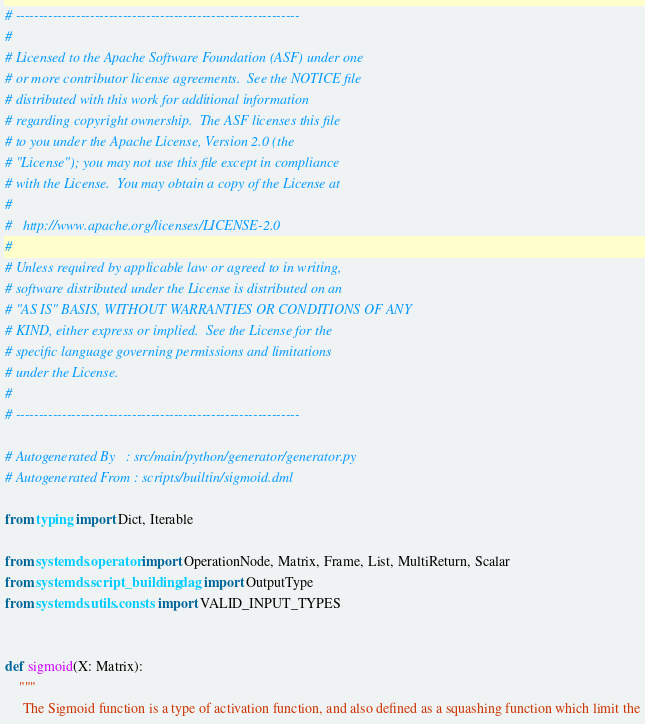<code> <loc_0><loc_0><loc_500><loc_500><_Python_># -------------------------------------------------------------
#
# Licensed to the Apache Software Foundation (ASF) under one
# or more contributor license agreements.  See the NOTICE file
# distributed with this work for additional information
# regarding copyright ownership.  The ASF licenses this file
# to you under the Apache License, Version 2.0 (the
# "License"); you may not use this file except in compliance
# with the License.  You may obtain a copy of the License at
#
#   http://www.apache.org/licenses/LICENSE-2.0
#
# Unless required by applicable law or agreed to in writing,
# software distributed under the License is distributed on an
# "AS IS" BASIS, WITHOUT WARRANTIES OR CONDITIONS OF ANY
# KIND, either express or implied.  See the License for the
# specific language governing permissions and limitations
# under the License.
#
# -------------------------------------------------------------

# Autogenerated By   : src/main/python/generator/generator.py
# Autogenerated From : scripts/builtin/sigmoid.dml

from typing import Dict, Iterable

from systemds.operator import OperationNode, Matrix, Frame, List, MultiReturn, Scalar
from systemds.script_building.dag import OutputType
from systemds.utils.consts import VALID_INPUT_TYPES


def sigmoid(X: Matrix):
    """
     The Sigmoid function is a type of activation function, and also defined as a squashing function which limit the</code> 